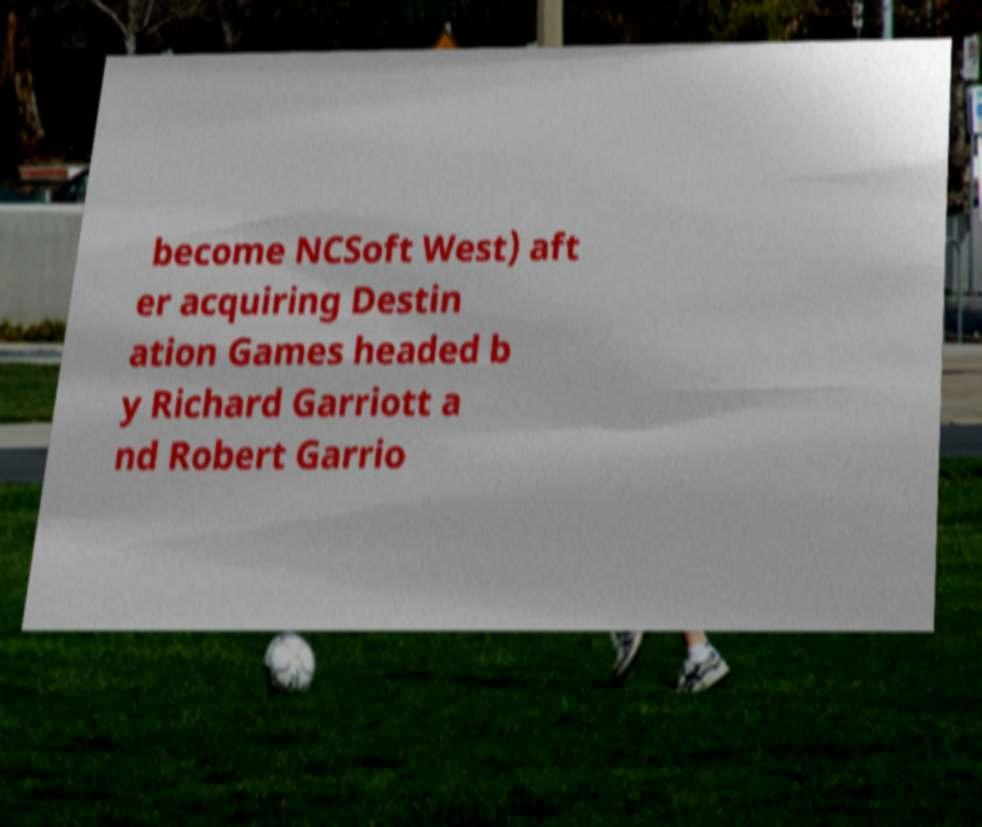Can you accurately transcribe the text from the provided image for me? become NCSoft West) aft er acquiring Destin ation Games headed b y Richard Garriott a nd Robert Garrio 